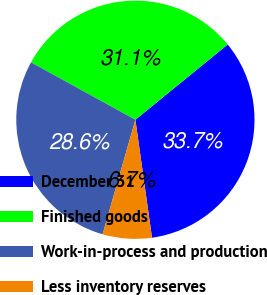Convert chart. <chart><loc_0><loc_0><loc_500><loc_500><pie_chart><fcel>December 31<fcel>Finished goods<fcel>Work-in-process and production<fcel>Less inventory reserves<nl><fcel>33.66%<fcel>31.11%<fcel>28.56%<fcel>6.67%<nl></chart> 